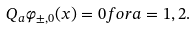Convert formula to latex. <formula><loc_0><loc_0><loc_500><loc_500>Q _ { a } \varphi _ { \pm , 0 } ( x ) = 0 f o r a = 1 , 2 .</formula> 